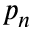Convert formula to latex. <formula><loc_0><loc_0><loc_500><loc_500>p _ { n }</formula> 